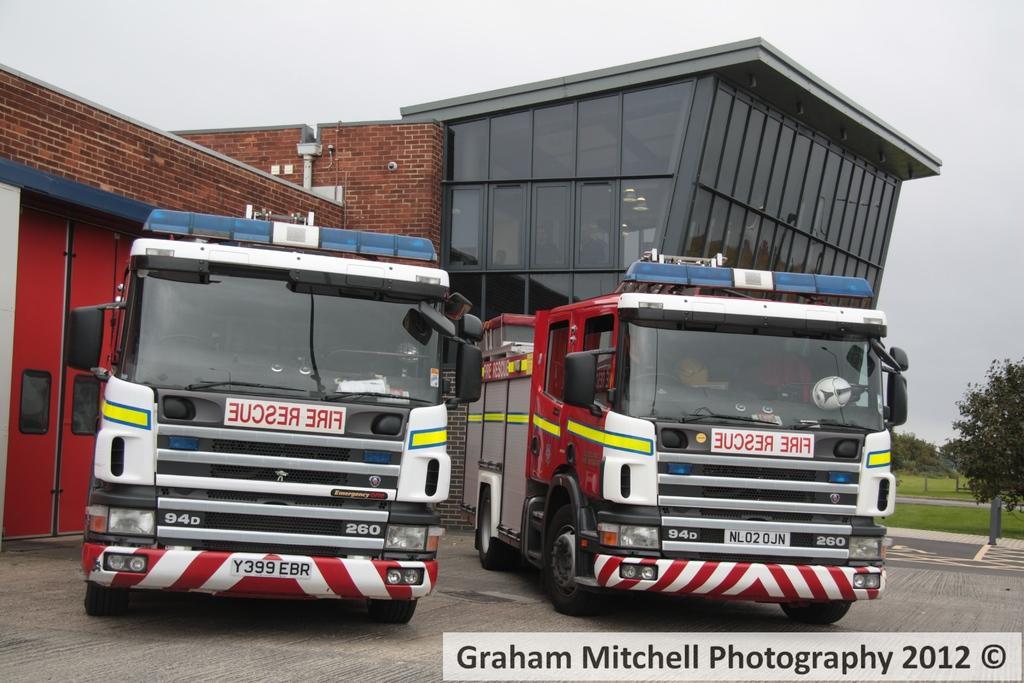Could you give a brief overview of what you see in this image? In the image there are two fire vehicles on the road with a building it, on the right side there are trees on the grassland and above its sky. 